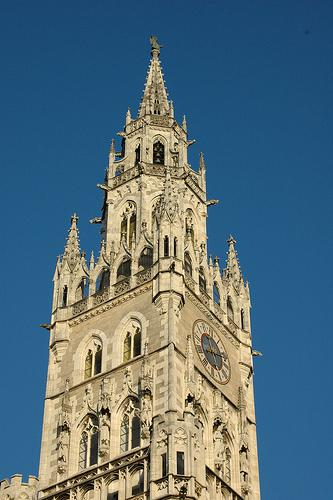Question: what is the weather like behind the clock?
Choices:
A. It is clear and sunny.
B. Rainy.
C. Snowing.
D. Cloudy.
Answer with the letter. Answer: A Question: what color is the building?
Choices:
A. Its color is red.
B. Its color is tan.
C. Its color is black.
D. Its color is gray.
Answer with the letter. Answer: B Question: where is the clock?
Choices:
A. On the mantle.
B. On the dashboard.
C. On my desk.
D. On the building.
Answer with the letter. Answer: D Question: how many clocks are there?
Choices:
A. One clock.
B. Two clocks.
C. Three clocks.
D. Four clocks.
Answer with the letter. Answer: A 